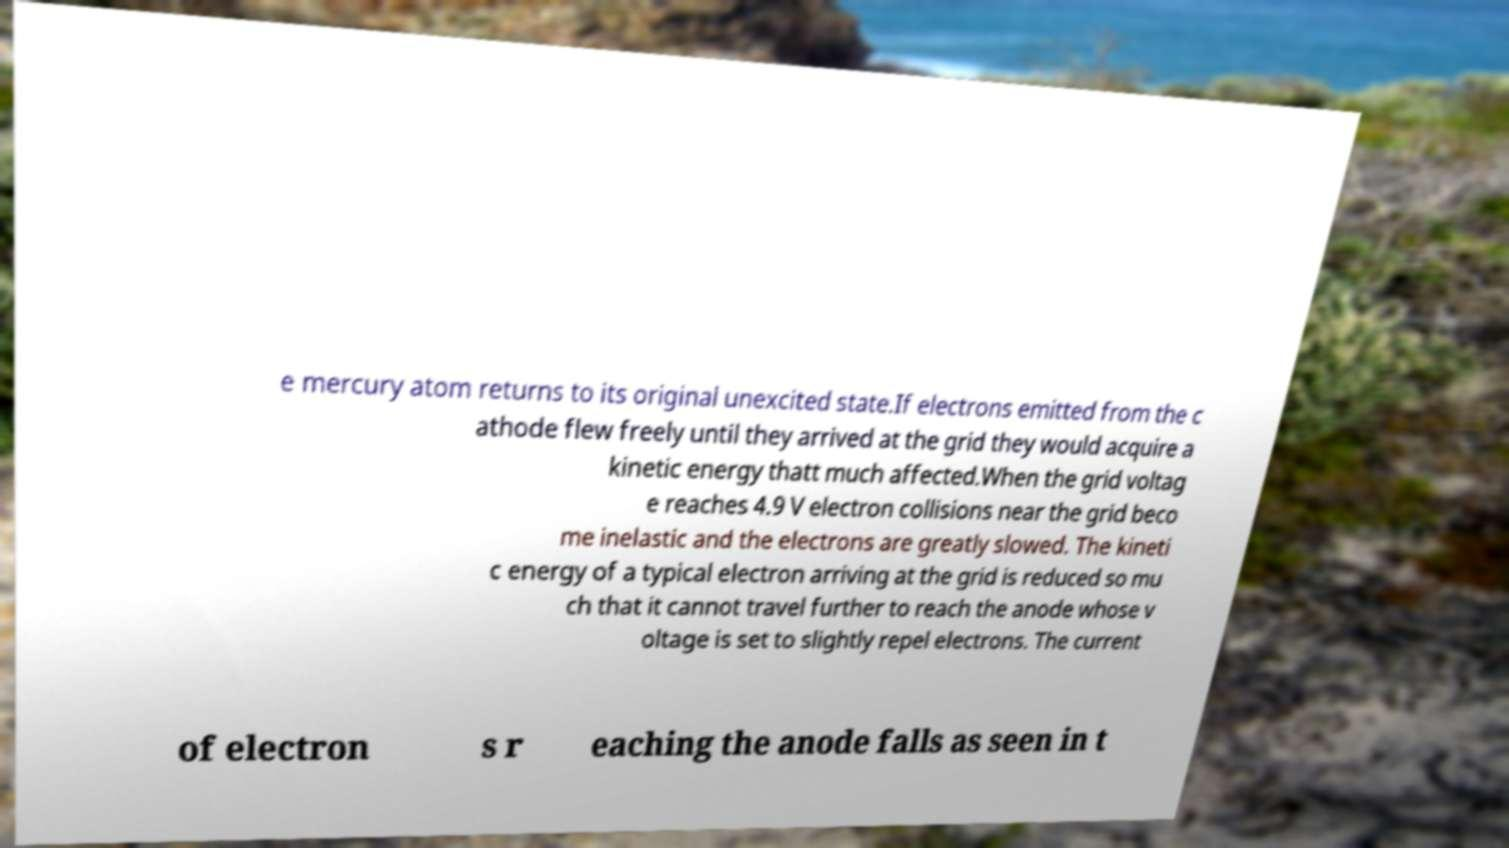For documentation purposes, I need the text within this image transcribed. Could you provide that? e mercury atom returns to its original unexcited state.If electrons emitted from the c athode flew freely until they arrived at the grid they would acquire a kinetic energy thatt much affected.When the grid voltag e reaches 4.9 V electron collisions near the grid beco me inelastic and the electrons are greatly slowed. The kineti c energy of a typical electron arriving at the grid is reduced so mu ch that it cannot travel further to reach the anode whose v oltage is set to slightly repel electrons. The current of electron s r eaching the anode falls as seen in t 